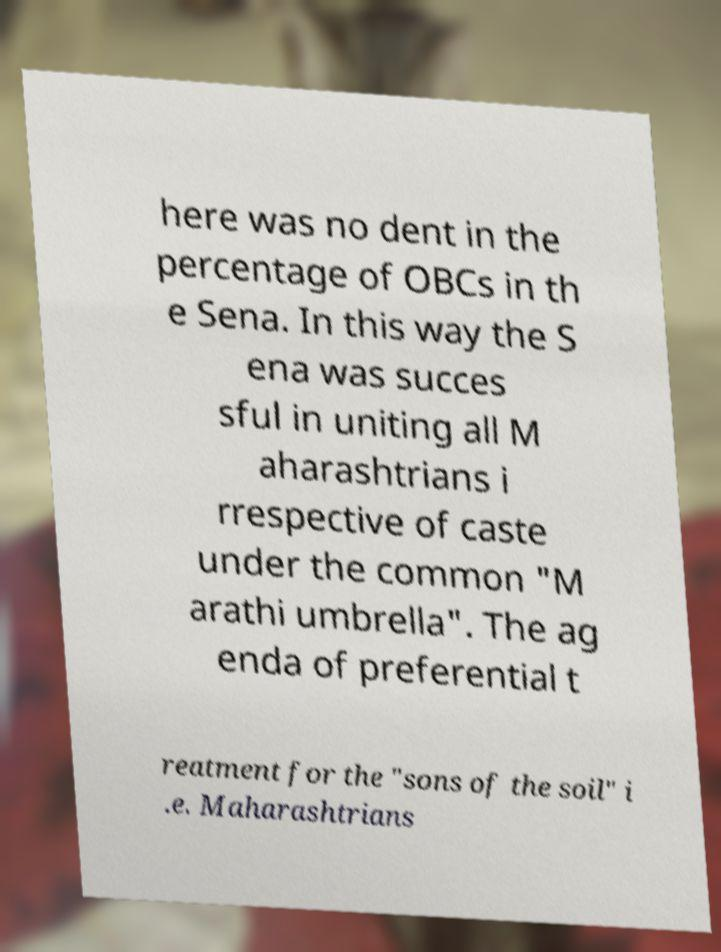Can you read and provide the text displayed in the image?This photo seems to have some interesting text. Can you extract and type it out for me? here was no dent in the percentage of OBCs in th e Sena. In this way the S ena was succes sful in uniting all M aharashtrians i rrespective of caste under the common "M arathi umbrella". The ag enda of preferential t reatment for the "sons of the soil" i .e. Maharashtrians 